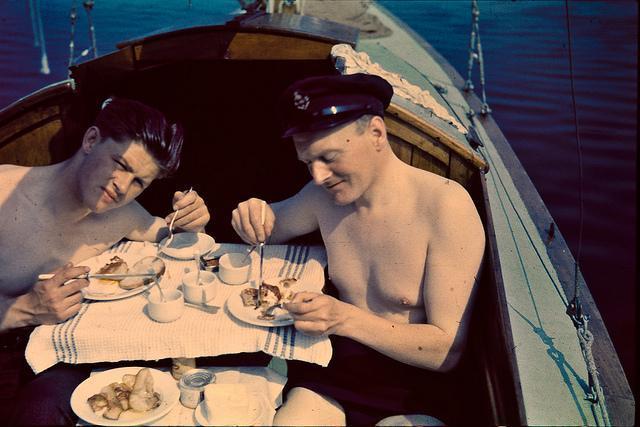How many people are there?
Give a very brief answer. 2. 